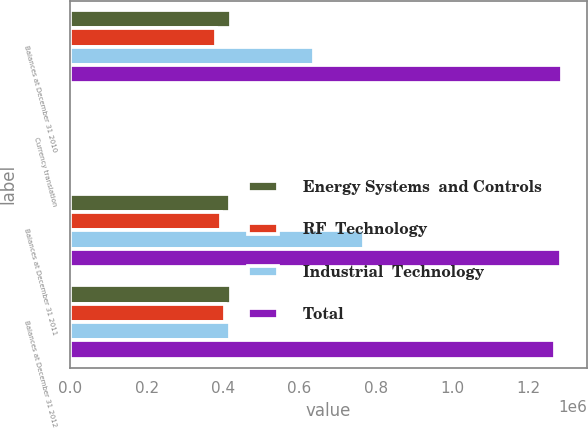Convert chart. <chart><loc_0><loc_0><loc_500><loc_500><stacked_bar_chart><ecel><fcel>Balances at December 31 2010<fcel>Currency translation<fcel>Balances at December 31 2011<fcel>Balances at December 31 2012<nl><fcel>Energy Systems  and Controls<fcel>420002<fcel>949<fcel>419053<fcel>421755<nl><fcel>RF  Technology<fcel>380595<fcel>291<fcel>393967<fcel>404057<nl><fcel>Industrial  Technology<fcel>637991<fcel>5142<fcel>768228<fcel>419053<nl><fcel>Total<fcel>1.28919e+06<fcel>1258<fcel>1.28518e+06<fcel>1.27064e+06<nl></chart> 